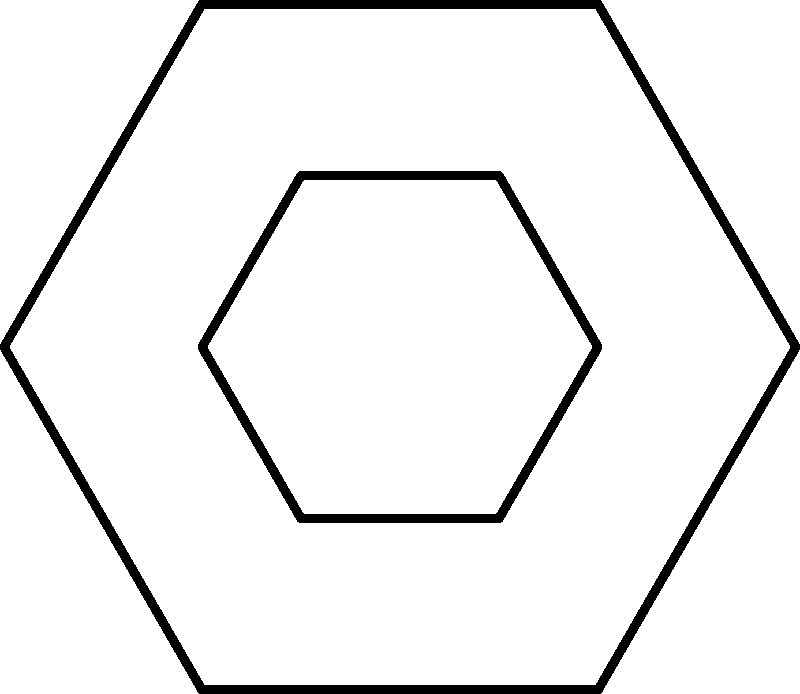In the symmetrical logo design shown above, which parts of the logo are congruent to the line segment connecting points A and 1? To identify the congruent parts in this symmetrical logo design, we need to follow these steps:

1. Observe that the logo consists of two regular hexagons - an outer one and an inner one - connected by six line segments.

2. The line segment connecting points A and 1 is one of these connecting segments.

3. Due to the symmetry of the regular hexagon, all sides of each hexagon are congruent to each other.

4. Additionally, the connecting segments between the outer and inner hexagons are all equal in length due to the uniform scaling of the inner hexagon.

5. Therefore, all six connecting segments (A1, B2, C3, D4, E5, and F6) are congruent to each other.

6. The symmetry of the logo ensures that these segments are not only equal in length but also in their orientation relative to the hexagons.

Thus, the line segments connecting points B and 2, C and 3, D and 4, E and 5, and F and 6 are all congruent to the line segment connecting A and 1.
Answer: B2, C3, D4, E5, F6 